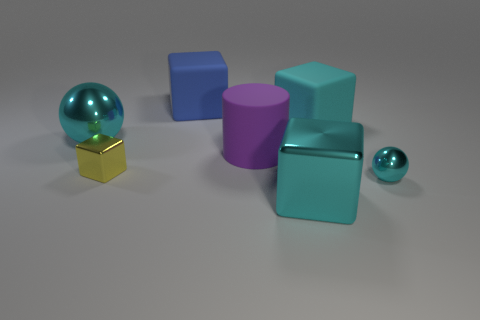Subtract all large cubes. How many cubes are left? 1 Subtract 3 blocks. How many blocks are left? 1 Subtract all yellow blocks. How many blocks are left? 3 Add 1 large cylinders. How many objects exist? 8 Subtract all cylinders. How many objects are left? 6 Subtract all brown cubes. Subtract all red cylinders. How many cubes are left? 4 Subtract all red spheres. How many blue blocks are left? 1 Subtract all big purple cylinders. Subtract all small yellow objects. How many objects are left? 5 Add 3 yellow cubes. How many yellow cubes are left? 4 Add 6 cubes. How many cubes exist? 10 